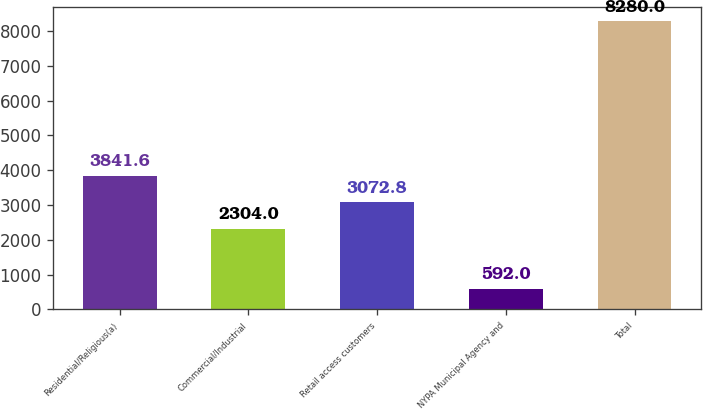Convert chart. <chart><loc_0><loc_0><loc_500><loc_500><bar_chart><fcel>Residential/Religious(a)<fcel>Commercial/Industrial<fcel>Retail access customers<fcel>NYPA Municipal Agency and<fcel>Total<nl><fcel>3841.6<fcel>2304<fcel>3072.8<fcel>592<fcel>8280<nl></chart> 